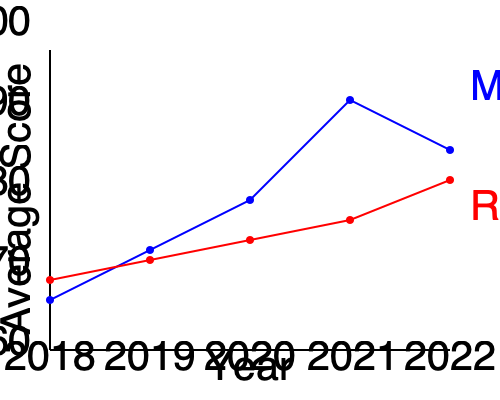As a superintendent analyzing student performance data, what critical insight can you draw from the trends in math and reading scores from 2018 to 2022, and what targeted intervention would you propose to address the most concerning trend? To answer this question, let's analyze the trends step-by-step:

1. Math scores (blue line):
   - 2018-2020: Steady increase from about 70 to 80
   - 2020-2021: Sharp increase from 80 to 90
   - 2021-2022: Decrease from 90 to 85

2. Reading scores (red line):
   - 2018-2020: Slight decrease from about 72 to 70
   - 2020-2022: Steady increase from 70 to 78

3. Critical insights:
   a) Math performance improved significantly from 2018 to 2021 but showed a decline in 2022.
   b) Reading performance initially declined but has shown consistent improvement since 2020.
   c) The gap between math and reading scores widened from 2018 to 2021 but narrowed in 2022.

4. Most concerning trend:
   The decline in math scores from 2021 to 2022 is the most alarming trend, as it reverses a positive multi-year trend and could indicate a systemic issue.

5. Targeted intervention:
   To address the decline in math scores, a comprehensive intervention could include:
   a) Conducting a detailed analysis of the 2021-2022 math curriculum and teaching methods
   b) Implementing additional support for math teachers through professional development
   c) Introducing targeted math tutoring programs for struggling students
   d) Increasing parent involvement in math education through workshops and at-home activities
   e) Utilizing data-driven instruction to identify and address specific areas of weakness in math skills

This intervention aims to halt the decline in math scores while maintaining the positive trend in reading performance.
Answer: The critical insight is the recent decline in math scores, requiring a targeted intervention focusing on curriculum review, teacher support, tutoring programs, parent involvement, and data-driven instruction in mathematics. 